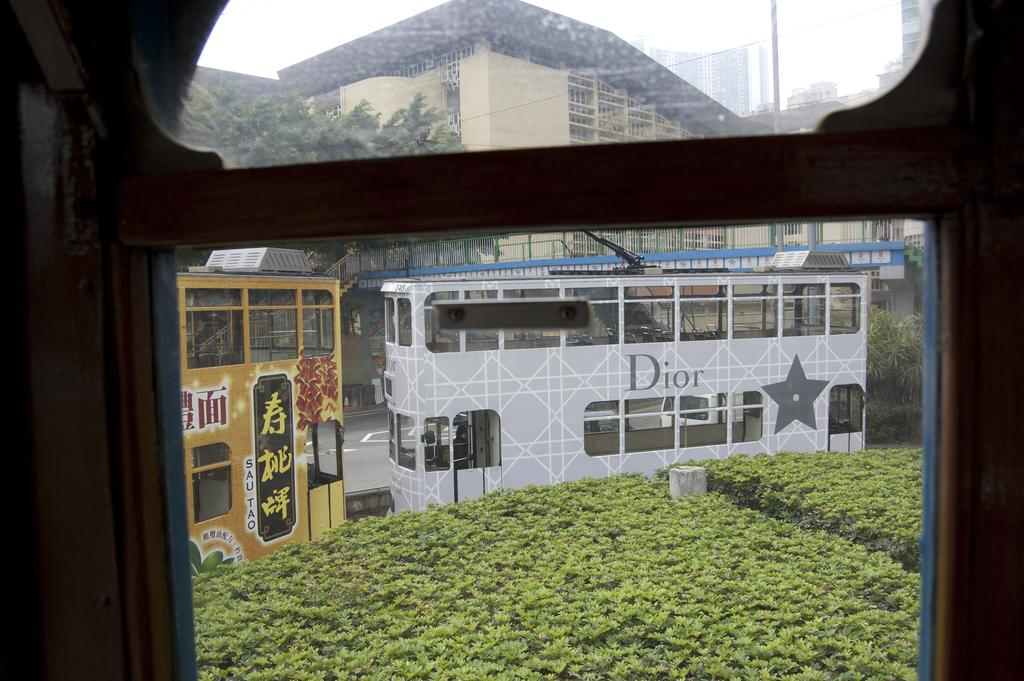What type of structures can be seen in the image? There are buildings in the image. What mode of transportation is present in the image? There are locomotives in the image. What type of architectural feature can be seen in the image? There are railings in the image. What utility infrastructure is visible in the image? There are electric poles and electric cables in the image. What type of vegetation is present in the image? There are bushes and trees in the image. What part of the natural environment is visible in the image? The sky is visible in the image. What type of grass is used to make the map in the image? There is no map or grass present in the image. How is the wax being used in the image? There is no wax present in the image. 